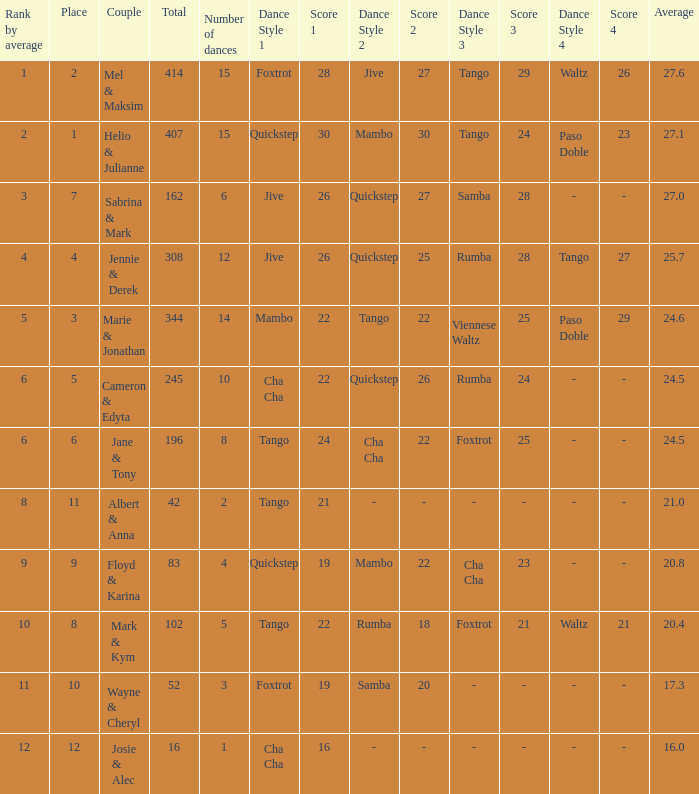What is the rank by average where the total was larger than 245 and the average was 27.1 with fewer than 15 dances? None. I'm looking to parse the entire table for insights. Could you assist me with that? {'header': ['Rank by average', 'Place', 'Couple', 'Total', 'Number of dances', 'Dance Style 1', 'Score 1', 'Dance Style 2', 'Score 2', 'Dance Style 3', 'Score 3', 'Dance Style 4', 'Score 4', 'Average'], 'rows': [['1', '2', 'Mel & Maksim', '414', '15', 'Foxtrot', '28', 'Jive', '27', 'Tango', '29', 'Waltz', '26', '27.6'], ['2', '1', 'Helio & Julianne', '407', '15', 'Quickstep', '30', 'Mambo', '30', 'Tango', '24', 'Paso Doble', '23', '27.1'], ['3', '7', 'Sabrina & Mark', '162', '6', 'Jive', '26', 'Quickstep', '27', 'Samba', '28', '-', '-', '27.0'], ['4', '4', 'Jennie & Derek', '308', '12', 'Jive', '26', 'Quickstep', '25', 'Rumba', '28', 'Tango', '27', '25.7'], ['5', '3', 'Marie & Jonathan', '344', '14', 'Mambo', '22', 'Tango', '22', 'Viennese Waltz', '25', 'Paso Doble', '29', '24.6'], ['6', '5', 'Cameron & Edyta', '245', '10', 'Cha Cha', '22', 'Quickstep', '26', 'Rumba', '24', '-', '-', '24.5'], ['6', '6', 'Jane & Tony', '196', '8', 'Tango', '24', 'Cha Cha', '22', 'Foxtrot', '25', '-', '-', '24.5'], ['8', '11', 'Albert & Anna', '42', '2', 'Tango', '21', '-', '-', '-', '-', '-', '-', '21.0'], ['9', '9', 'Floyd & Karina', '83', '4', 'Quickstep', '19', 'Mambo', '22', 'Cha Cha', '23', '-', '-', '20.8'], ['10', '8', 'Mark & Kym', '102', '5', 'Tango', '22', 'Rumba', '18', 'Foxtrot', '21', 'Waltz', '21', '20.4'], ['11', '10', 'Wayne & Cheryl', '52', '3', 'Foxtrot', '19', 'Samba', '20', '-', '-', '-', '-', '17.3'], ['12', '12', 'Josie & Alec', '16', '1', 'Cha Cha', '16', '-', '-', '-', '-', '-', '-', '16.0']]} 